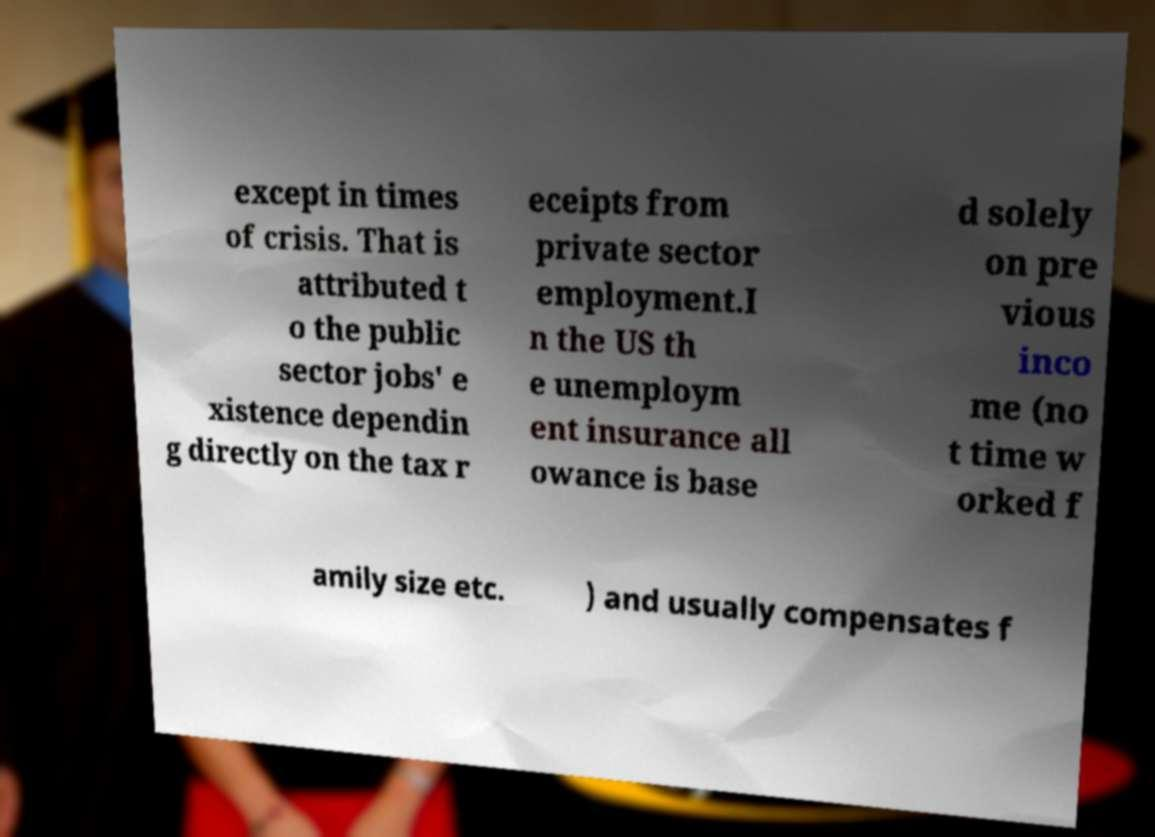For documentation purposes, I need the text within this image transcribed. Could you provide that? except in times of crisis. That is attributed t o the public sector jobs' e xistence dependin g directly on the tax r eceipts from private sector employment.I n the US th e unemploym ent insurance all owance is base d solely on pre vious inco me (no t time w orked f amily size etc. ) and usually compensates f 